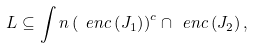Convert formula to latex. <formula><loc_0><loc_0><loc_500><loc_500>L \subseteq \int n \left ( \ e n c \left ( J _ { 1 } \right ) \right ) ^ { c } \cap \ e n c \left ( J _ { 2 } \right ) ,</formula> 